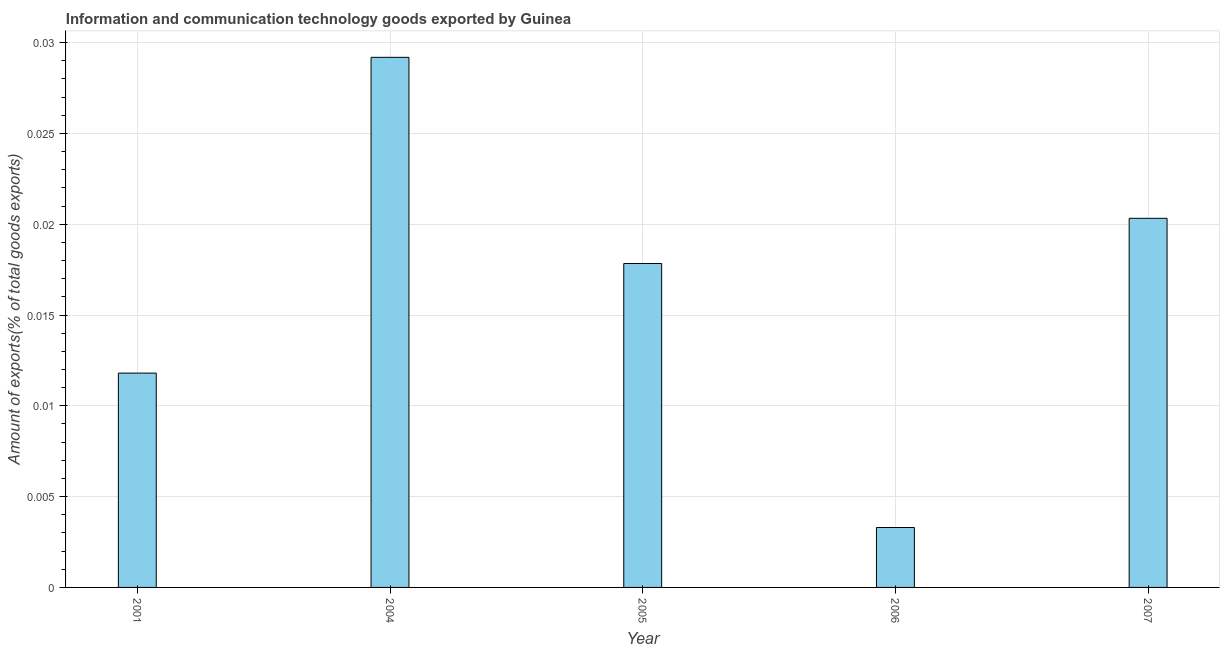Does the graph contain any zero values?
Your answer should be very brief. No. Does the graph contain grids?
Give a very brief answer. Yes. What is the title of the graph?
Make the answer very short. Information and communication technology goods exported by Guinea. What is the label or title of the X-axis?
Offer a terse response. Year. What is the label or title of the Y-axis?
Keep it short and to the point. Amount of exports(% of total goods exports). What is the amount of ict goods exports in 2007?
Offer a very short reply. 0.02. Across all years, what is the maximum amount of ict goods exports?
Your answer should be very brief. 0.03. Across all years, what is the minimum amount of ict goods exports?
Provide a short and direct response. 0. In which year was the amount of ict goods exports minimum?
Your response must be concise. 2006. What is the sum of the amount of ict goods exports?
Your response must be concise. 0.08. What is the difference between the amount of ict goods exports in 2001 and 2006?
Your answer should be compact. 0.01. What is the average amount of ict goods exports per year?
Make the answer very short. 0.02. What is the median amount of ict goods exports?
Your answer should be very brief. 0.02. In how many years, is the amount of ict goods exports greater than 0.017 %?
Give a very brief answer. 3. What is the ratio of the amount of ict goods exports in 2005 to that in 2007?
Ensure brevity in your answer.  0.88. What is the difference between the highest and the second highest amount of ict goods exports?
Give a very brief answer. 0.01. Is the sum of the amount of ict goods exports in 2006 and 2007 greater than the maximum amount of ict goods exports across all years?
Your answer should be compact. No. What is the difference between the highest and the lowest amount of ict goods exports?
Provide a succinct answer. 0.03. In how many years, is the amount of ict goods exports greater than the average amount of ict goods exports taken over all years?
Offer a very short reply. 3. How many bars are there?
Ensure brevity in your answer.  5. Are all the bars in the graph horizontal?
Give a very brief answer. No. How many years are there in the graph?
Your response must be concise. 5. What is the difference between two consecutive major ticks on the Y-axis?
Provide a succinct answer. 0.01. What is the Amount of exports(% of total goods exports) in 2001?
Provide a short and direct response. 0.01. What is the Amount of exports(% of total goods exports) in 2004?
Your answer should be compact. 0.03. What is the Amount of exports(% of total goods exports) of 2005?
Your answer should be very brief. 0.02. What is the Amount of exports(% of total goods exports) in 2006?
Ensure brevity in your answer.  0. What is the Amount of exports(% of total goods exports) of 2007?
Offer a very short reply. 0.02. What is the difference between the Amount of exports(% of total goods exports) in 2001 and 2004?
Provide a succinct answer. -0.02. What is the difference between the Amount of exports(% of total goods exports) in 2001 and 2005?
Ensure brevity in your answer.  -0.01. What is the difference between the Amount of exports(% of total goods exports) in 2001 and 2006?
Your answer should be compact. 0.01. What is the difference between the Amount of exports(% of total goods exports) in 2001 and 2007?
Provide a short and direct response. -0.01. What is the difference between the Amount of exports(% of total goods exports) in 2004 and 2005?
Provide a succinct answer. 0.01. What is the difference between the Amount of exports(% of total goods exports) in 2004 and 2006?
Your answer should be compact. 0.03. What is the difference between the Amount of exports(% of total goods exports) in 2004 and 2007?
Keep it short and to the point. 0.01. What is the difference between the Amount of exports(% of total goods exports) in 2005 and 2006?
Your answer should be compact. 0.01. What is the difference between the Amount of exports(% of total goods exports) in 2005 and 2007?
Ensure brevity in your answer.  -0. What is the difference between the Amount of exports(% of total goods exports) in 2006 and 2007?
Give a very brief answer. -0.02. What is the ratio of the Amount of exports(% of total goods exports) in 2001 to that in 2004?
Offer a terse response. 0.4. What is the ratio of the Amount of exports(% of total goods exports) in 2001 to that in 2005?
Your answer should be very brief. 0.66. What is the ratio of the Amount of exports(% of total goods exports) in 2001 to that in 2006?
Provide a short and direct response. 3.58. What is the ratio of the Amount of exports(% of total goods exports) in 2001 to that in 2007?
Provide a short and direct response. 0.58. What is the ratio of the Amount of exports(% of total goods exports) in 2004 to that in 2005?
Give a very brief answer. 1.64. What is the ratio of the Amount of exports(% of total goods exports) in 2004 to that in 2006?
Make the answer very short. 8.85. What is the ratio of the Amount of exports(% of total goods exports) in 2004 to that in 2007?
Your answer should be very brief. 1.44. What is the ratio of the Amount of exports(% of total goods exports) in 2005 to that in 2006?
Give a very brief answer. 5.41. What is the ratio of the Amount of exports(% of total goods exports) in 2005 to that in 2007?
Offer a terse response. 0.88. What is the ratio of the Amount of exports(% of total goods exports) in 2006 to that in 2007?
Ensure brevity in your answer.  0.16. 